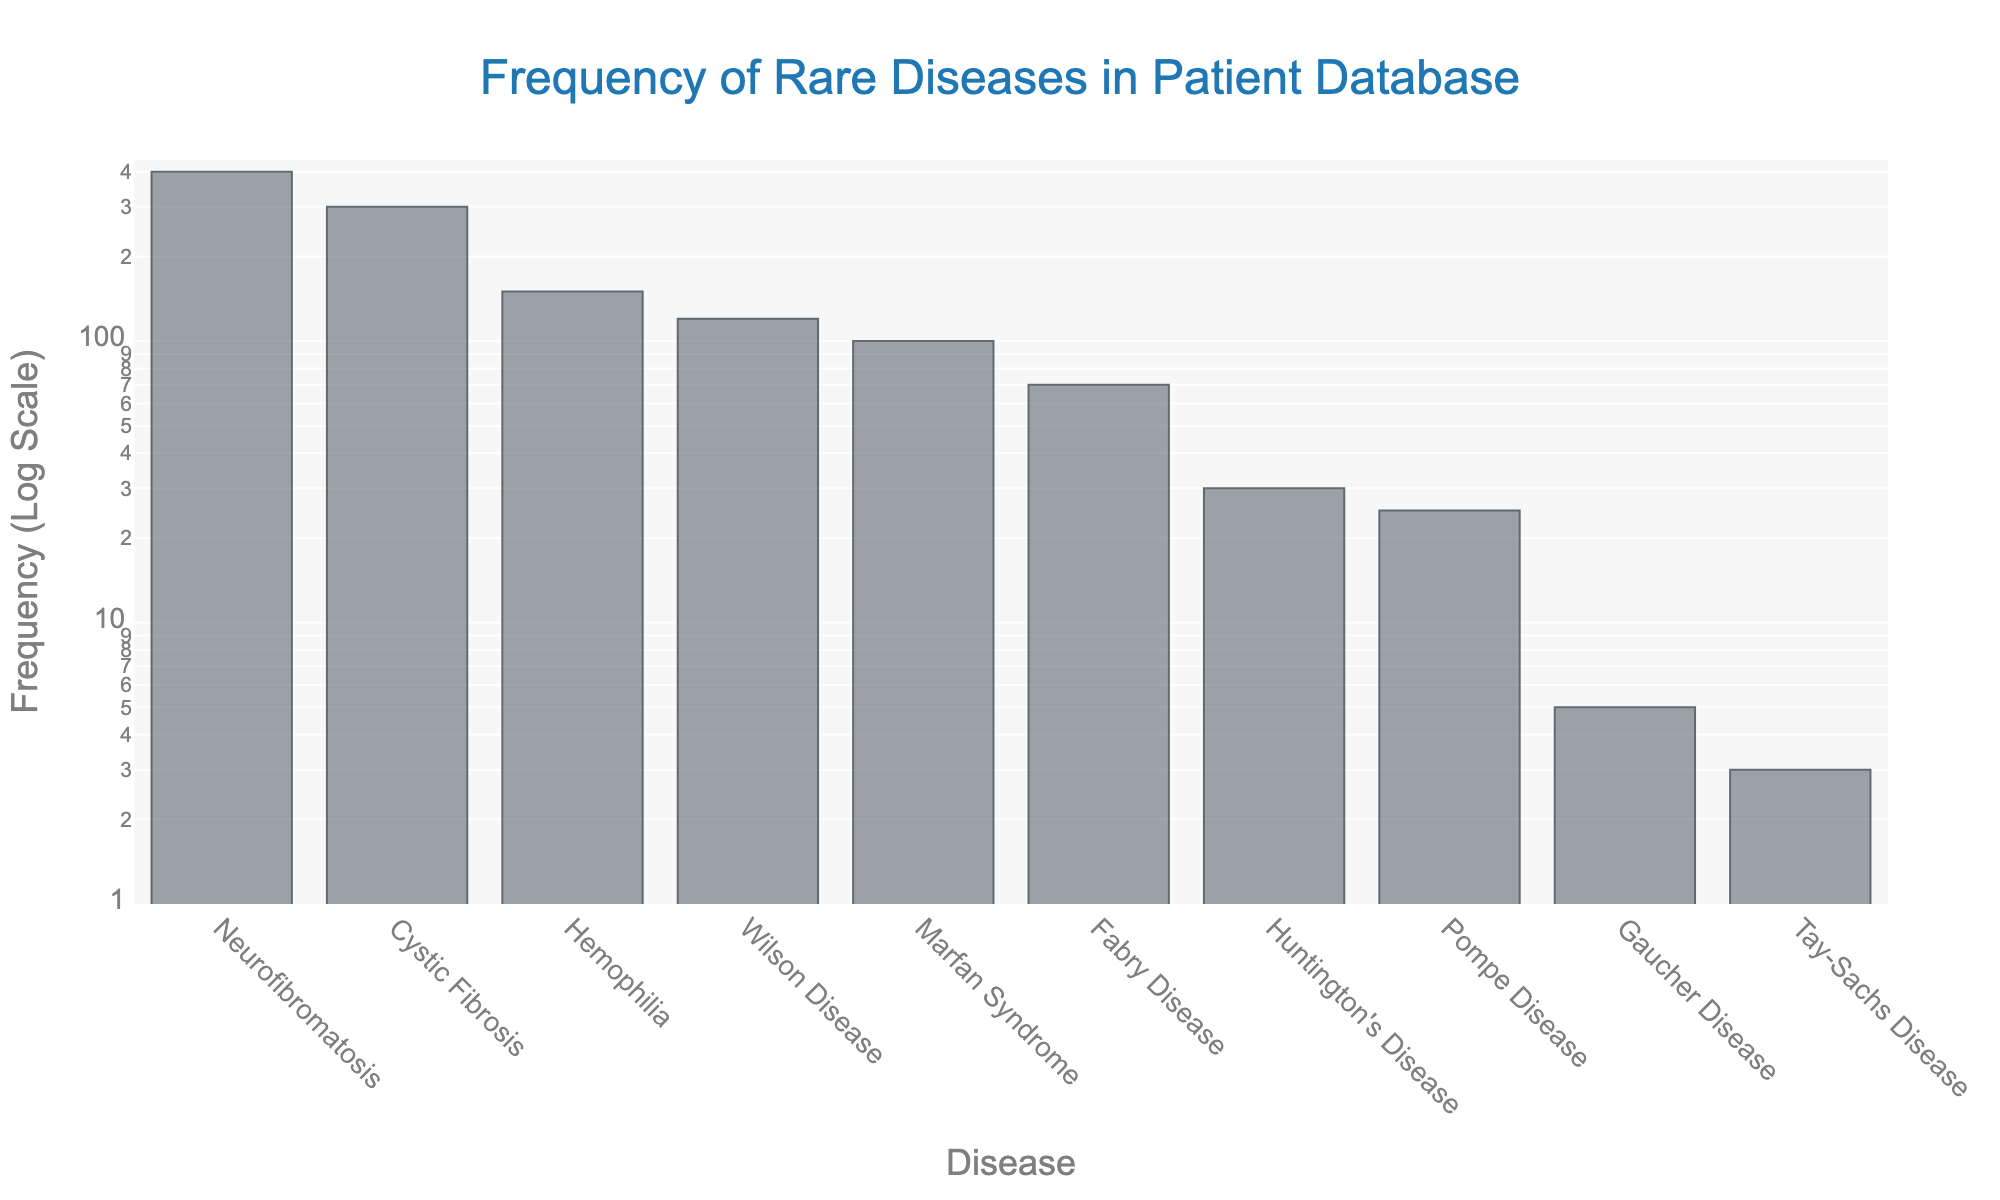Which disease has the highest frequency? The plot shows the frequency of various rare diseases. By examining the bar heights, the disease with the highest bar represents the highest frequency.
Answer: Neurofibromatosis Which disease has the lowest frequency? The plot shows the frequency of various rare diseases. By examining the bar heights, the disease with the lowest bar represents the lowest frequency.
Answer: Tay-Sachs Disease How many diseases have a frequency greater than 100? We need to count the number of bars exceeding the frequency of 100. By observing the y-axis (with a log scale) and the corresponding bar lengths, we identify those diseases.
Answer: 5 What is the combined frequency of Gaucher Disease and Huntington's Disease? The frequency of Gaucher Disease and Huntington's Disease is provided in the plot. Adding their frequencies: 5 (Gaucher) + 30 (Huntington's) = 35.
Answer: 35 Which disease has approximately half the frequency of Cystic Fibrosis? Cystic Fibrosis has a frequency of 300. We need to find the disease with a frequency around 150. By examining the plot, this disease is identified.
Answer: Hemophilia What are the three diseases with the lowest frequencies? The plot shows the diseases ordered by frequencies. The three shortest bars correspond to the three diseases with the lowest frequencies.
Answer: Tay-Sachs Disease, Gaucher Disease, Pompe Disease Is the frequency of Marfan Syndrome greater than Wilson Disease? We compare the heights of the bars representing Marfan Syndrome and Wilson Disease. The bar for Marfan Syndrome is shorter.
Answer: No What is the median frequency of the listed diseases? To determine the median, we sort the frequencies in ascending order and select the middle value. Sorted frequencies are: 3, 5, 25, 30, 70, 100, 120, 150, 300, 400. Median of 10 values is the average of the 5th and 6th values: (70+100)/2 = 85.
Answer: 85 How does the frequency distribution appear on a log scale? The log scale on the y-axis compresses the range, making it easier to discern variations among smaller and larger frequencies. Most frequencies appear closer together due to the scaling.
Answer: Compressed towards the lower end of the y-axis Which disease has the closest frequency to 100? By examining the plot, we look for the bar closest to the 100 mark on the logarithmic scale.
Answer: Marfan Syndrome 